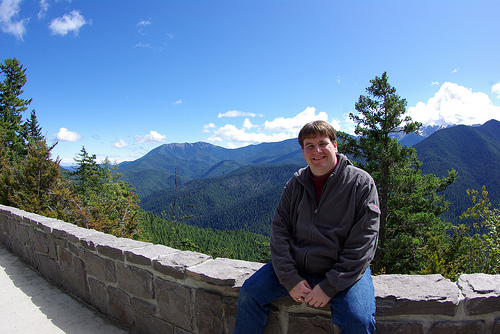<image>
Can you confirm if the man is on the wall? Yes. Looking at the image, I can see the man is positioned on top of the wall, with the wall providing support. Is the person under the tree? No. The person is not positioned under the tree. The vertical relationship between these objects is different. Is the man in the wall? No. The man is not contained within the wall. These objects have a different spatial relationship. 